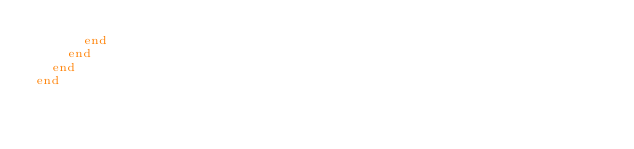<code> <loc_0><loc_0><loc_500><loc_500><_Ruby_>      end
    end
  end
end
</code> 